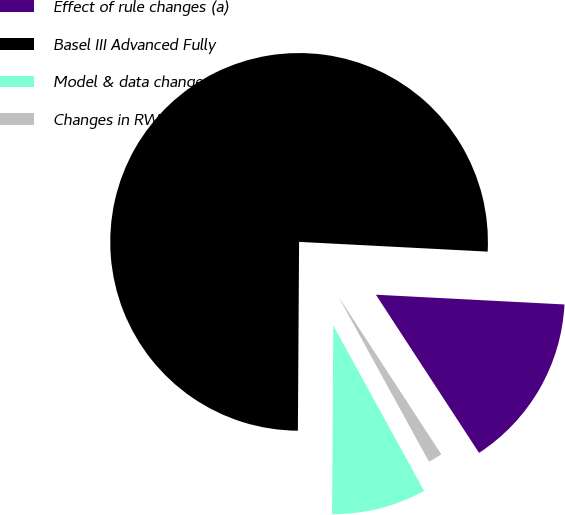<chart> <loc_0><loc_0><loc_500><loc_500><pie_chart><fcel>Effect of rule changes (a)<fcel>Basel III Advanced Fully<fcel>Model & data changes (b)<fcel>Changes in RWA<nl><fcel>14.98%<fcel>75.72%<fcel>8.09%<fcel>1.21%<nl></chart> 